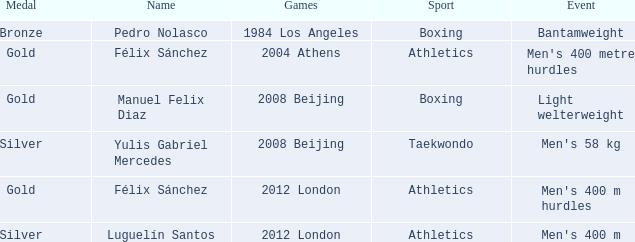In what sport did men's 400 m hurdles take place as an event? Athletics. 